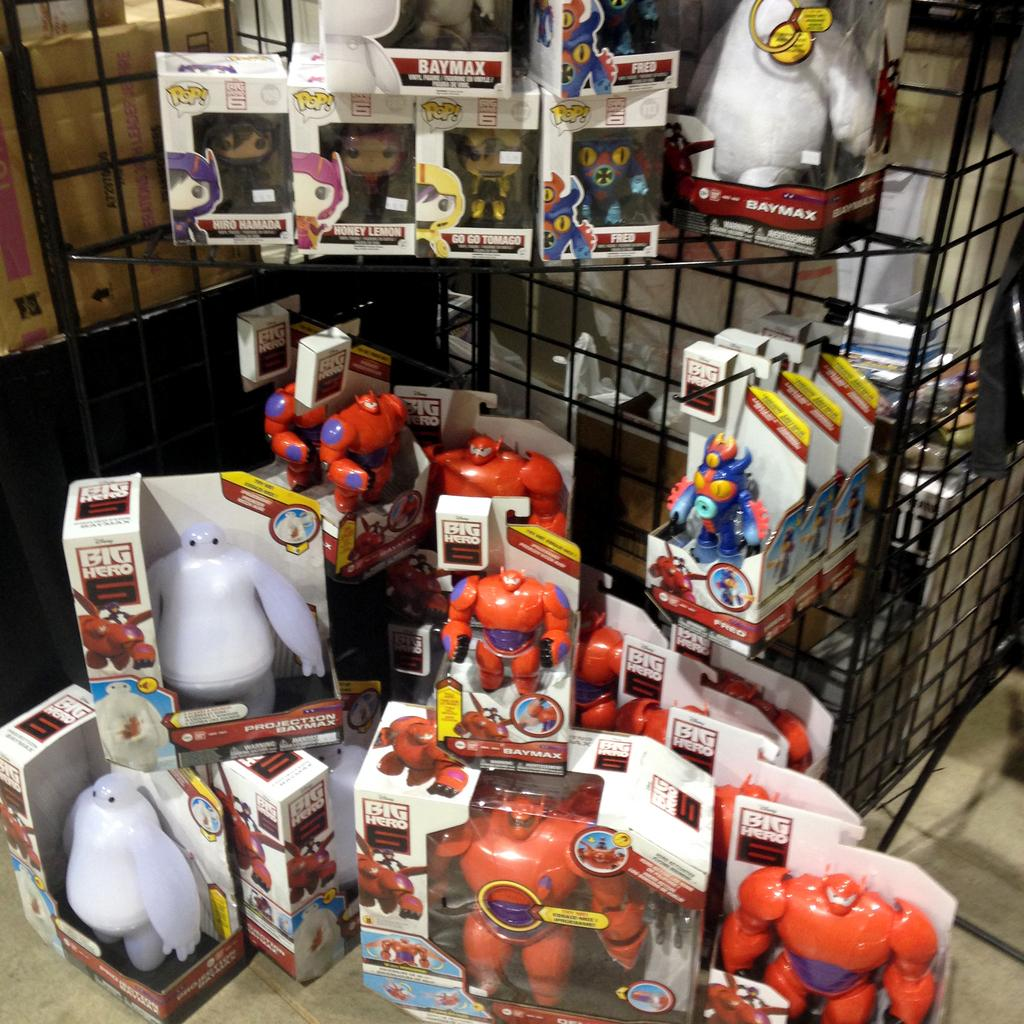What can be seen in the image? There are many toys in the image. How are the toys arranged or stored? The toys are packed into boxes. Can you describe the background of the image? There is a stand with different toys in the background. What is located on the left side of the image? There is a cardboard box on the left side of the image. What color is the orange in the image? There is no orange present in the image; it only features toys packed into boxes and a stand with different toys in the background. 